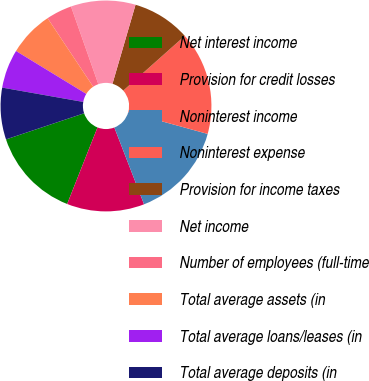Convert chart to OTSL. <chart><loc_0><loc_0><loc_500><loc_500><pie_chart><fcel>Net interest income<fcel>Provision for credit losses<fcel>Noninterest income<fcel>Noninterest expense<fcel>Provision for income taxes<fcel>Net income<fcel>Number of employees (full-time<fcel>Total average assets (in<fcel>Total average loans/leases (in<fcel>Total average deposits (in<nl><fcel>13.86%<fcel>11.88%<fcel>14.85%<fcel>15.84%<fcel>8.91%<fcel>9.9%<fcel>3.96%<fcel>6.93%<fcel>5.94%<fcel>7.92%<nl></chart> 